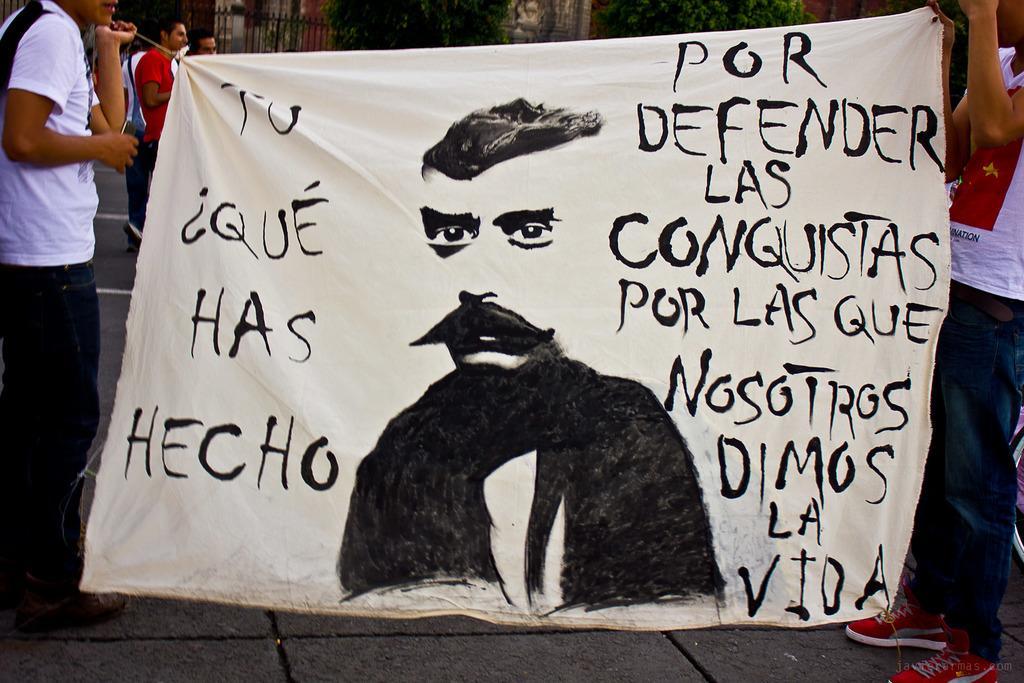Could you give a brief overview of what you see in this image? On either side of the picture, we see two men are standing. They are holding a white banner with some text written on it. At the bottom, we see the pavement. Behind the banner, we see the people are standing. In the background, we see the railing. We even see the wall and the trees. 